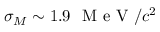<formula> <loc_0><loc_0><loc_500><loc_500>\sigma _ { M } \sim 1 . 9 M e V / c ^ { 2 }</formula> 